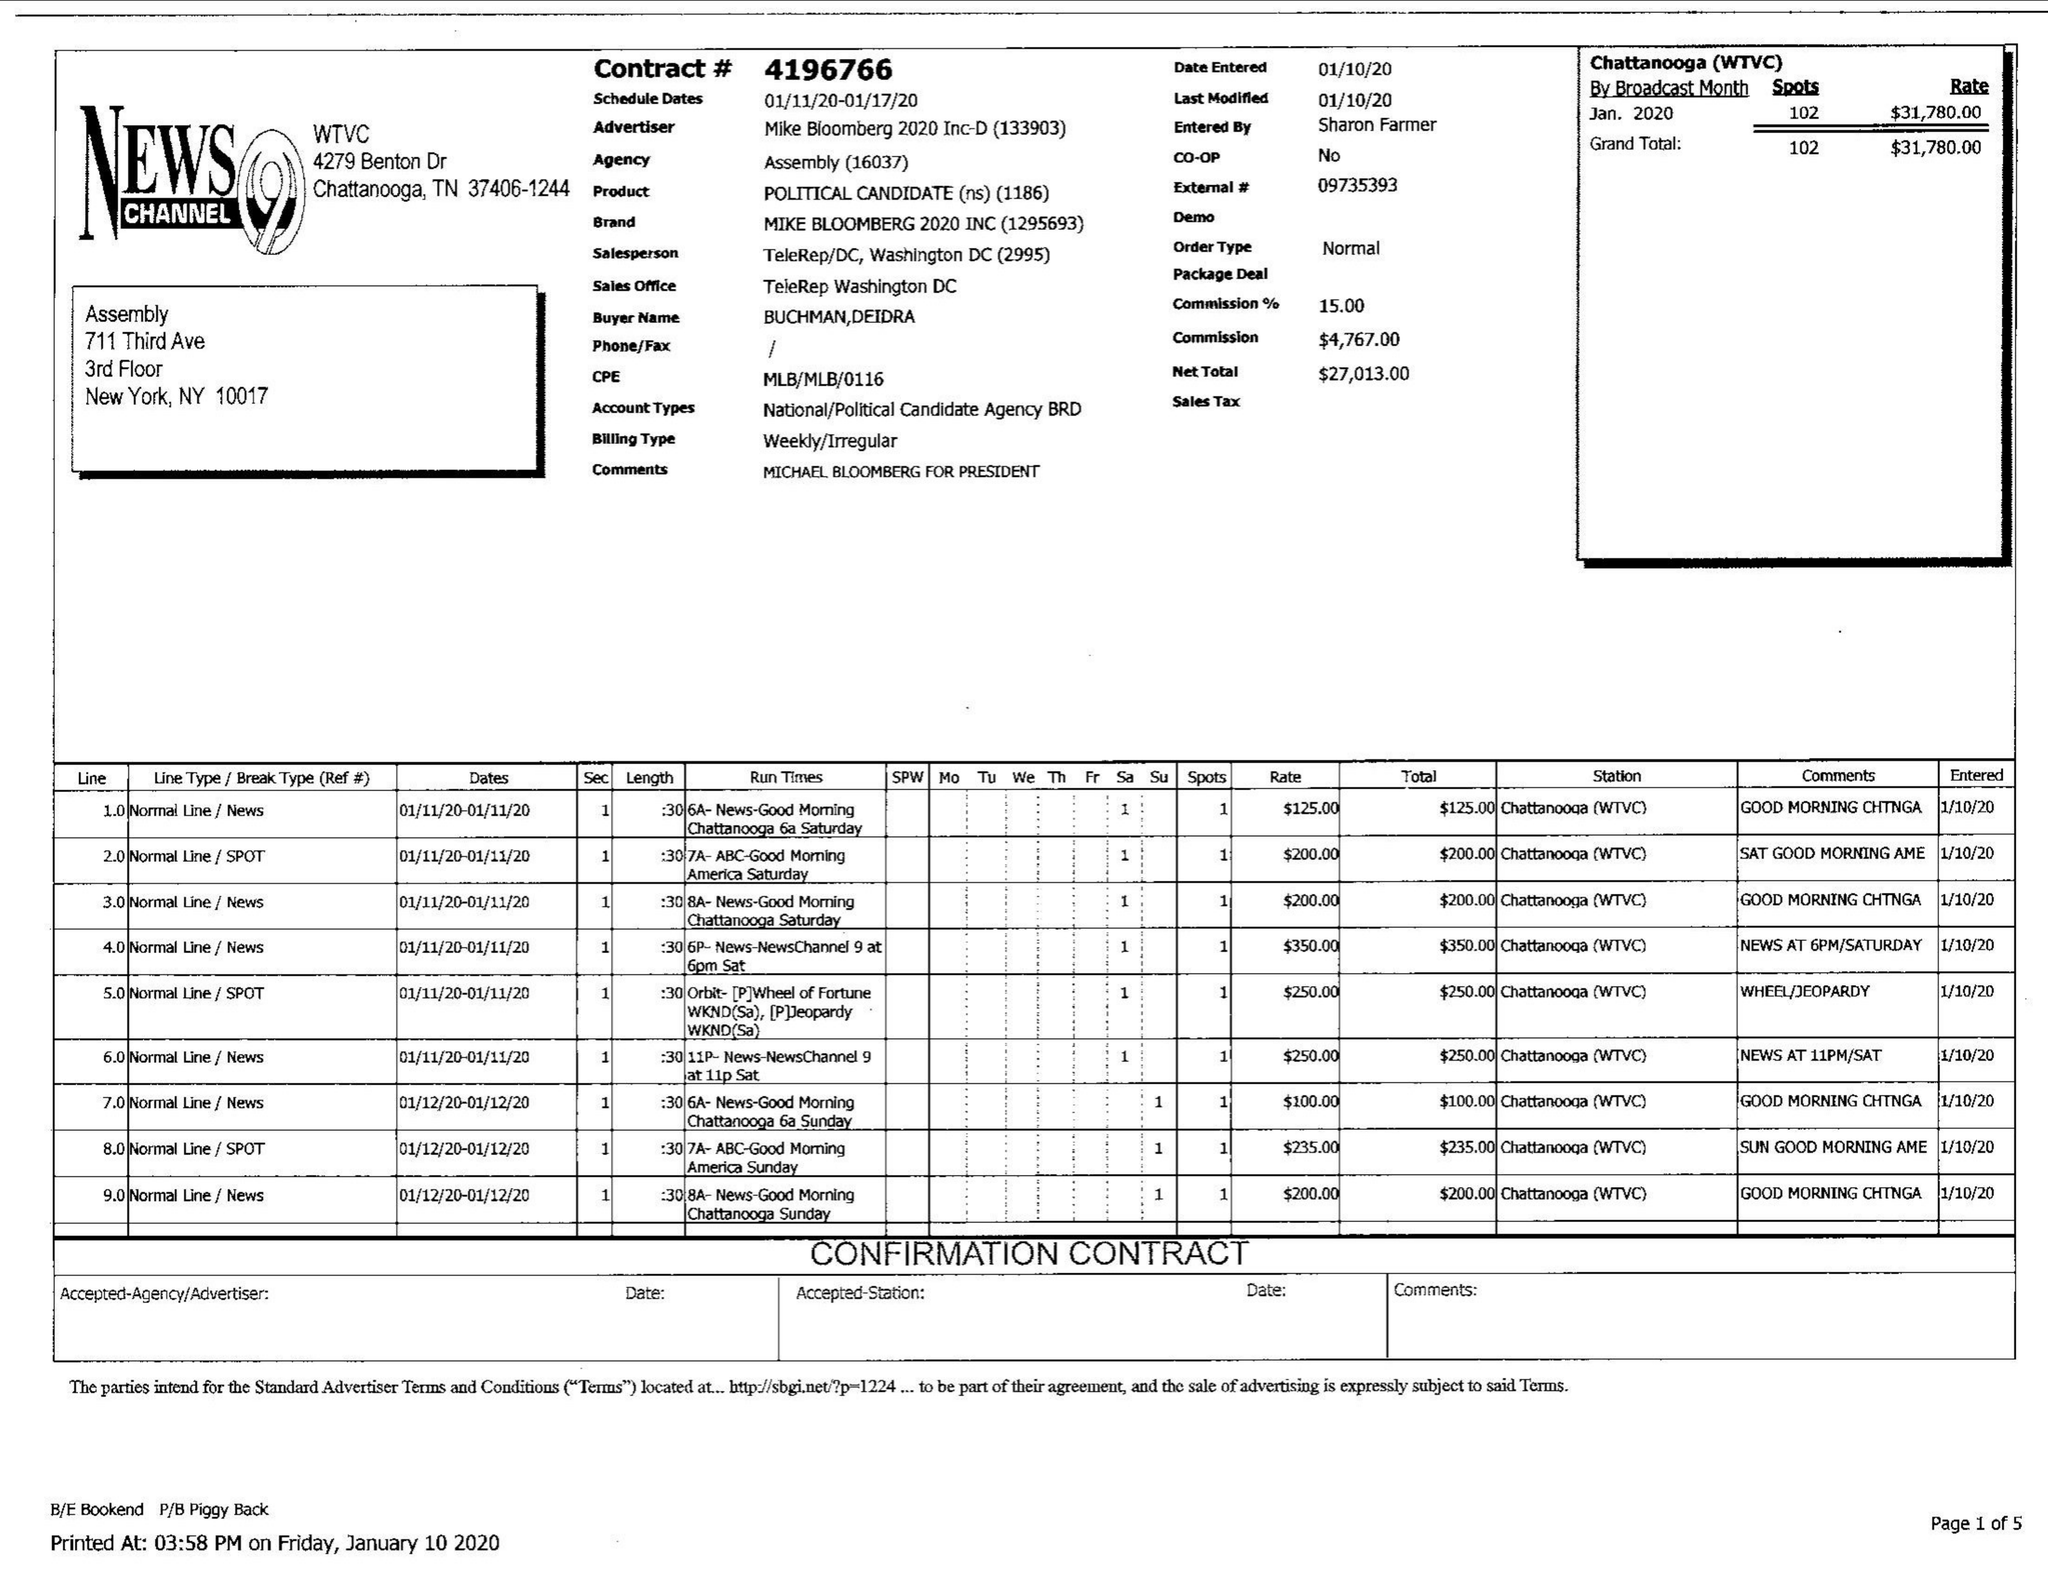What is the value for the gross_amount?
Answer the question using a single word or phrase. 31780.00 